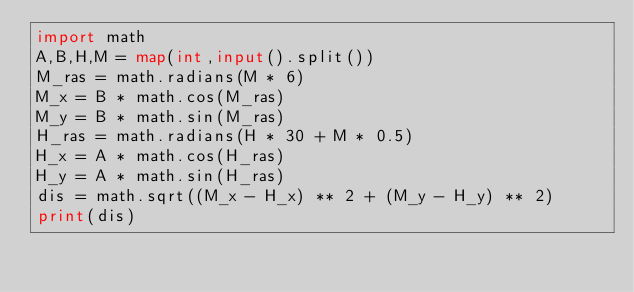<code> <loc_0><loc_0><loc_500><loc_500><_Python_>import math
A,B,H,M = map(int,input().split())
M_ras = math.radians(M * 6)
M_x = B * math.cos(M_ras)
M_y = B * math.sin(M_ras)
H_ras = math.radians(H * 30 + M * 0.5)
H_x = A * math.cos(H_ras)
H_y = A * math.sin(H_ras)
dis = math.sqrt((M_x - H_x) ** 2 + (M_y - H_y) ** 2)
print(dis)</code> 